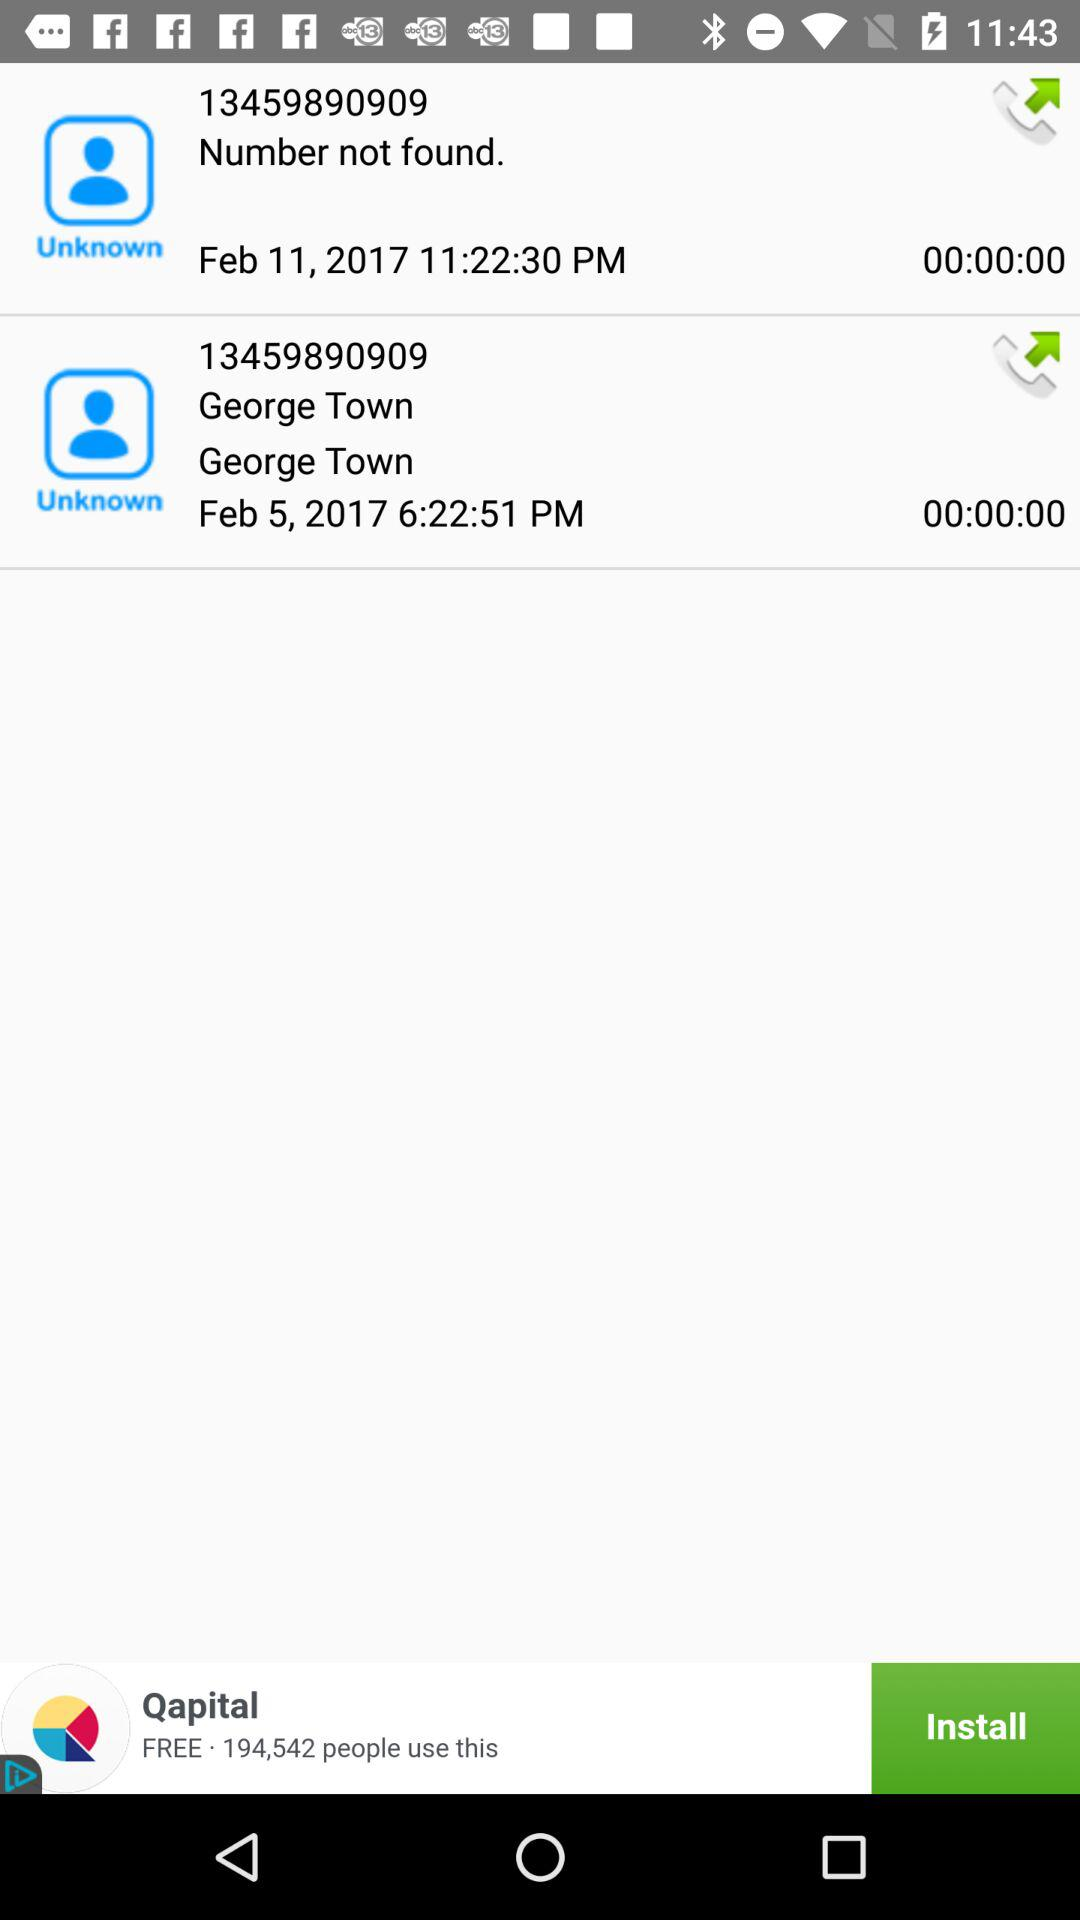What number is showing on February 11? The number is 13459890909. 